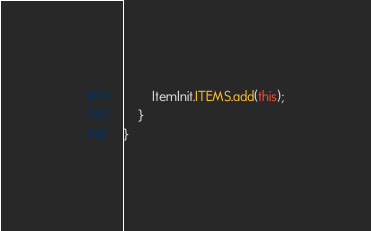<code> <loc_0><loc_0><loc_500><loc_500><_Java_>        ItemInit.ITEMS.add(this);
    }
}
</code> 